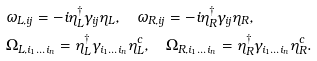Convert formula to latex. <formula><loc_0><loc_0><loc_500><loc_500>& \omega _ { L , i j } = - i \eta _ { L } ^ { \dagger } \gamma _ { i j } \eta _ { L } , \quad \omega _ { R , i j } = - i \eta _ { R } ^ { \dagger } \gamma _ { i j } \eta _ { R } , \\ & \Omega _ { L , i _ { 1 } \dots i _ { n } } = \eta _ { L } ^ { \dagger } \gamma _ { i _ { 1 } \dots i _ { n } } \eta ^ { c } _ { L } , \quad \Omega _ { R , i _ { 1 } \dots i _ { n } } = \eta _ { R } ^ { \dagger } \gamma _ { i _ { 1 } \dots i _ { n } } \eta ^ { c } _ { R } .</formula> 